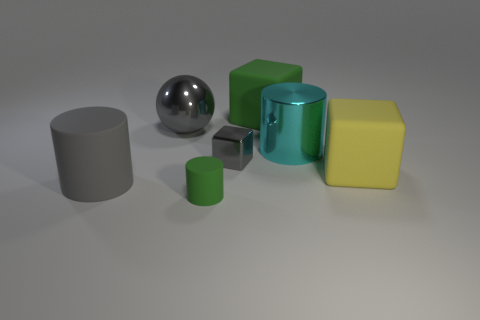What can you tell me about the texture of the objects in the image? The image displays objects with a variety of textures. The large spheres, both gray and shiny, have smooth surfaces that give a sense of sleekness, particularly noticeable with the reflective properties of the shiny sphere. Meanwhile, the cubes and cylinders appear to have a matte finish, which doesn't reflect light as prominently, resulting in a more subdued appearance. 